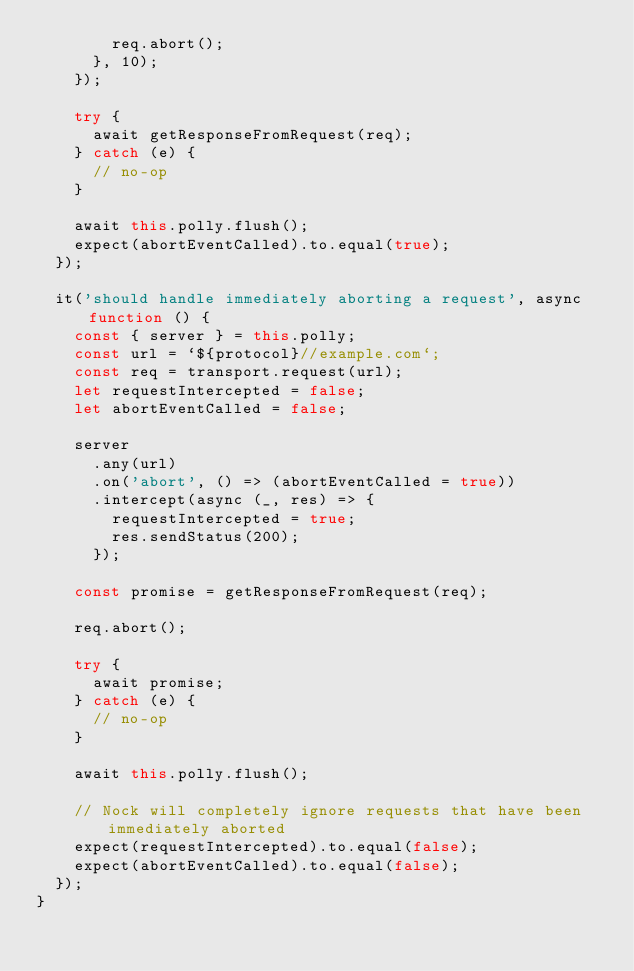Convert code to text. <code><loc_0><loc_0><loc_500><loc_500><_JavaScript_>        req.abort();
      }, 10);
    });

    try {
      await getResponseFromRequest(req);
    } catch (e) {
      // no-op
    }

    await this.polly.flush();
    expect(abortEventCalled).to.equal(true);
  });

  it('should handle immediately aborting a request', async function () {
    const { server } = this.polly;
    const url = `${protocol}//example.com`;
    const req = transport.request(url);
    let requestIntercepted = false;
    let abortEventCalled = false;

    server
      .any(url)
      .on('abort', () => (abortEventCalled = true))
      .intercept(async (_, res) => {
        requestIntercepted = true;
        res.sendStatus(200);
      });

    const promise = getResponseFromRequest(req);

    req.abort();

    try {
      await promise;
    } catch (e) {
      // no-op
    }

    await this.polly.flush();

    // Nock will completely ignore requests that have been immediately aborted
    expect(requestIntercepted).to.equal(false);
    expect(abortEventCalled).to.equal(false);
  });
}
</code> 